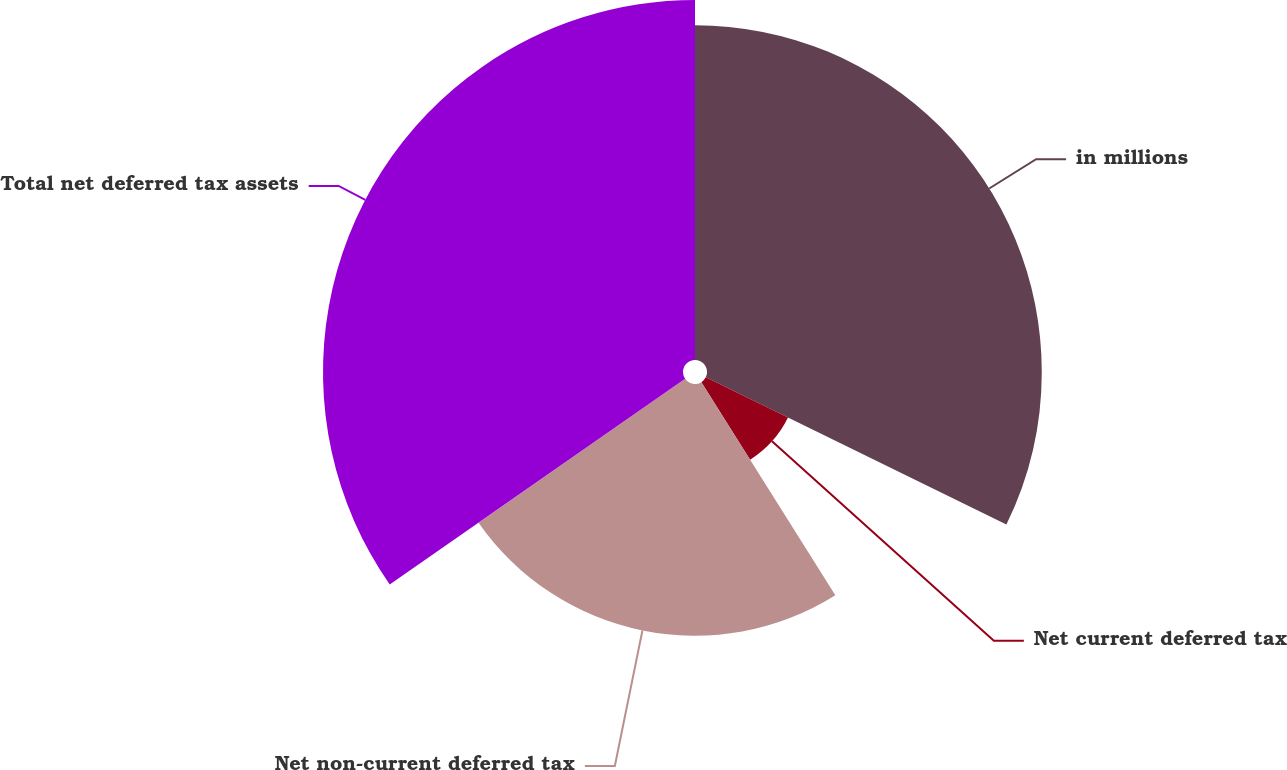Convert chart to OTSL. <chart><loc_0><loc_0><loc_500><loc_500><pie_chart><fcel>in millions<fcel>Net current deferred tax<fcel>Net non-current deferred tax<fcel>Total net deferred tax assets<nl><fcel>32.25%<fcel>8.82%<fcel>24.25%<fcel>34.68%<nl></chart> 